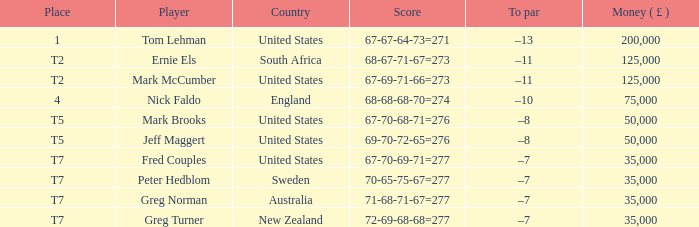What is Score, when Country is "United States", and when Player is "Mark Brooks"? 67-70-68-71=276. Write the full table. {'header': ['Place', 'Player', 'Country', 'Score', 'To par', 'Money ( £ )'], 'rows': [['1', 'Tom Lehman', 'United States', '67-67-64-73=271', '–13', '200,000'], ['T2', 'Ernie Els', 'South Africa', '68-67-71-67=273', '–11', '125,000'], ['T2', 'Mark McCumber', 'United States', '67-69-71-66=273', '–11', '125,000'], ['4', 'Nick Faldo', 'England', '68-68-68-70=274', '–10', '75,000'], ['T5', 'Mark Brooks', 'United States', '67-70-68-71=276', '–8', '50,000'], ['T5', 'Jeff Maggert', 'United States', '69-70-72-65=276', '–8', '50,000'], ['T7', 'Fred Couples', 'United States', '67-70-69-71=277', '–7', '35,000'], ['T7', 'Peter Hedblom', 'Sweden', '70-65-75-67=277', '–7', '35,000'], ['T7', 'Greg Norman', 'Australia', '71-68-71-67=277', '–7', '35,000'], ['T7', 'Greg Turner', 'New Zealand', '72-69-68-68=277', '–7', '35,000']]} 